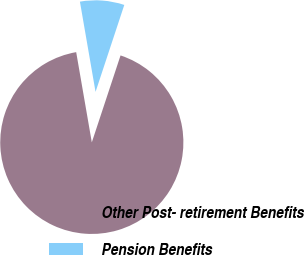Convert chart. <chart><loc_0><loc_0><loc_500><loc_500><pie_chart><fcel>Other Post- retirement Benefits<fcel>Pension Benefits<nl><fcel>92.19%<fcel>7.81%<nl></chart> 